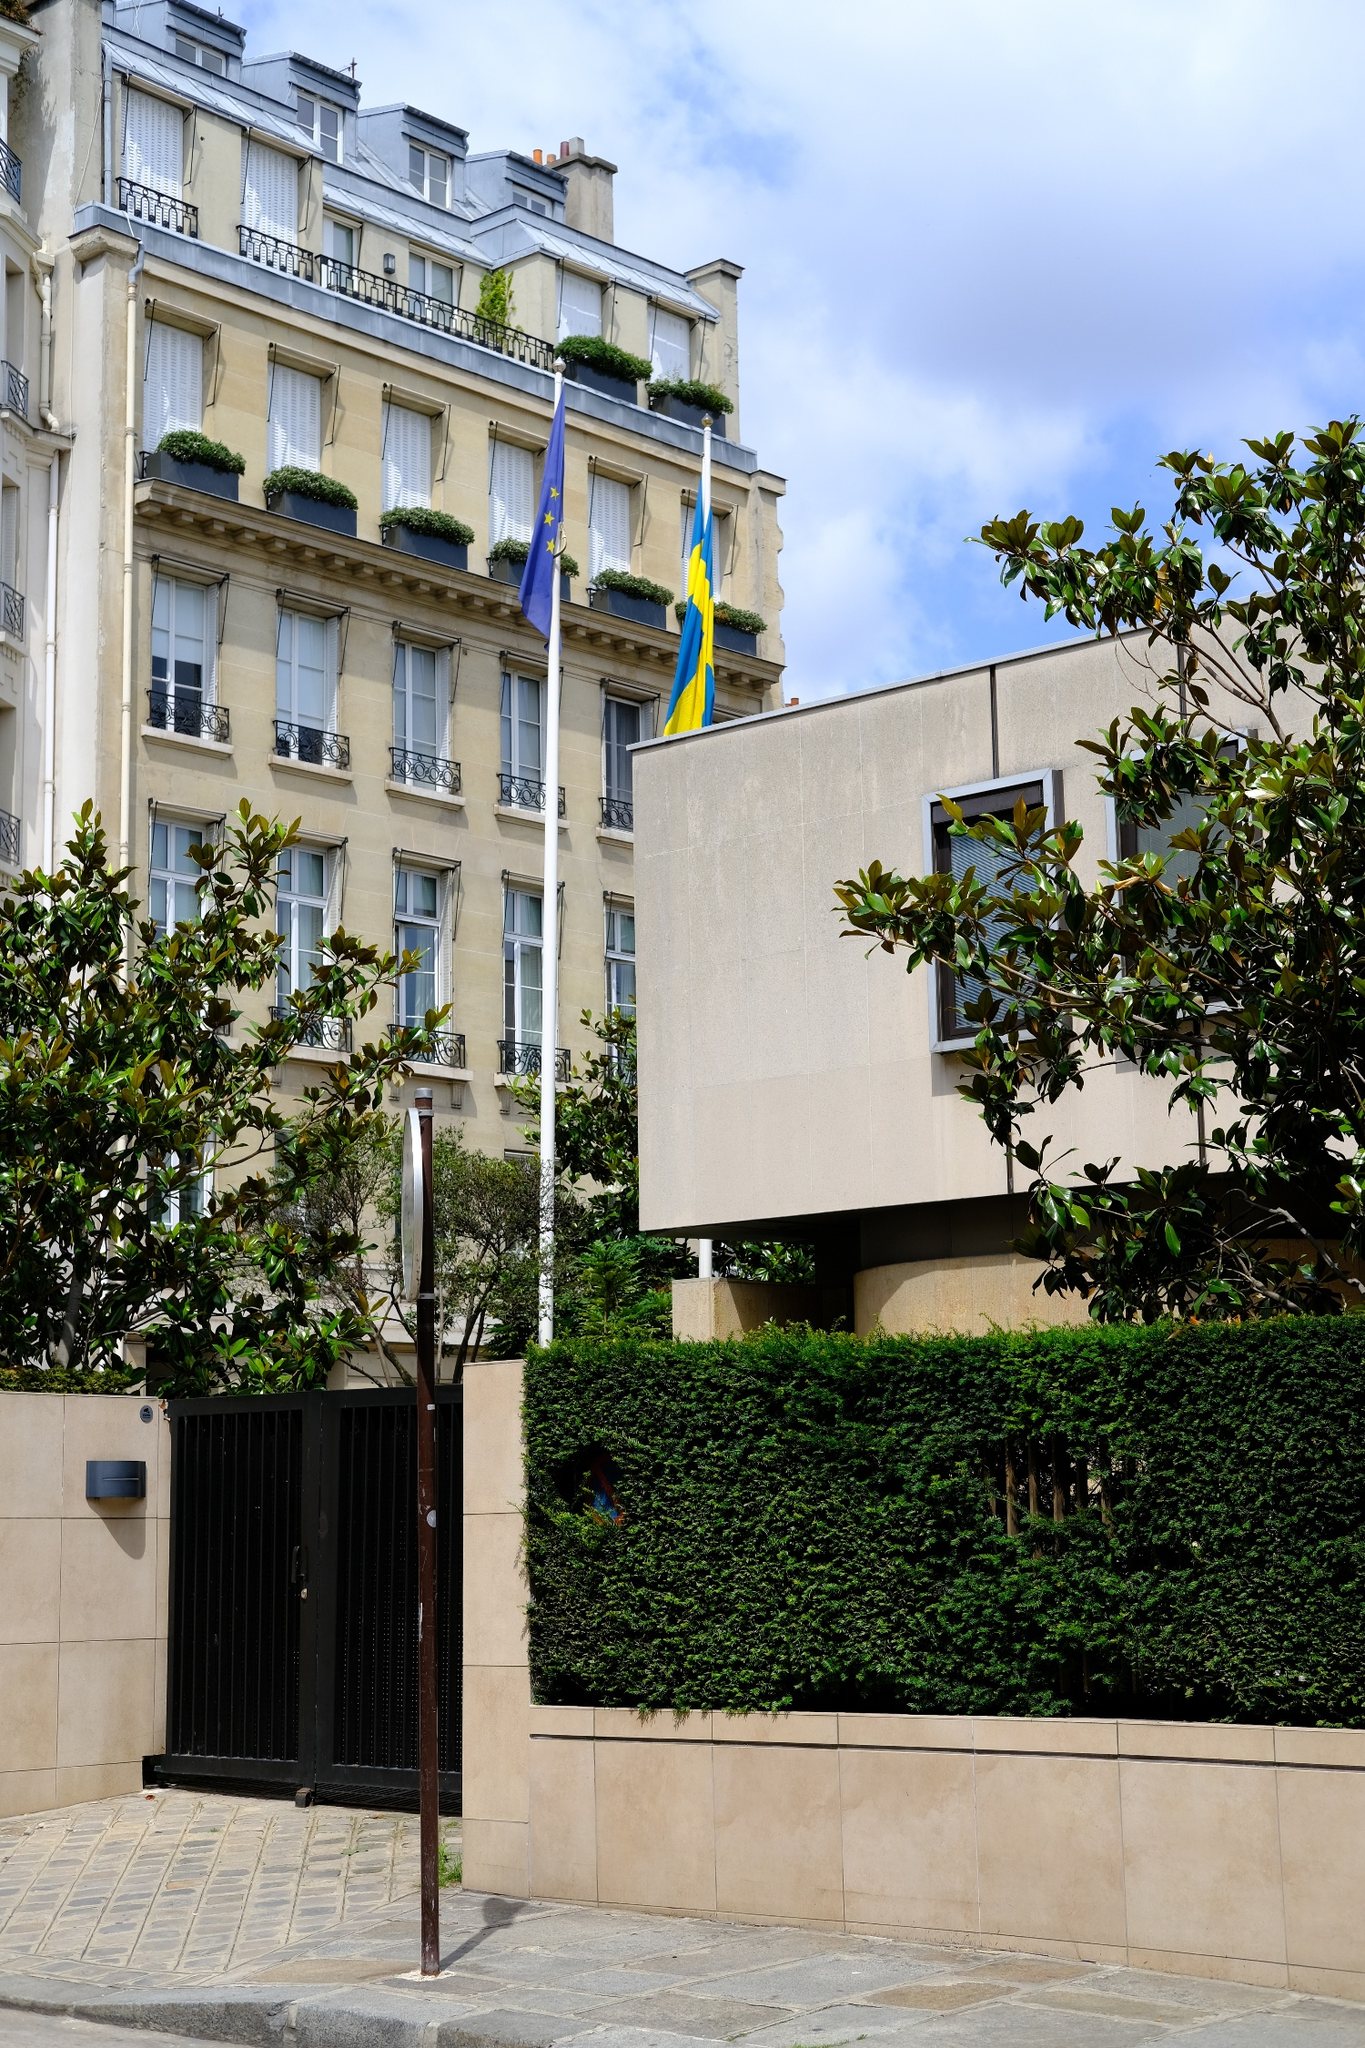Can you tell me more about the building's architectural style? The building showcased in the image features classic European architectural styles, which can often be seen across various cities in France. It's characterized by its stately, beige exterior with well-proportioned windows, each topped with detailed cornices and complemented by intricately designed wrought iron balcony railings. The uppermost level showcases dormer windows that pierce through the roof, a hallmark of historic European architecture that adds an element of charm and elegance to the structure. 